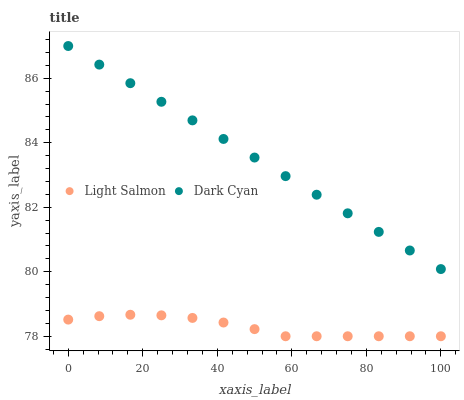Does Light Salmon have the minimum area under the curve?
Answer yes or no. Yes. Does Dark Cyan have the maximum area under the curve?
Answer yes or no. Yes. Does Light Salmon have the maximum area under the curve?
Answer yes or no. No. Is Dark Cyan the smoothest?
Answer yes or no. Yes. Is Light Salmon the roughest?
Answer yes or no. Yes. Is Light Salmon the smoothest?
Answer yes or no. No. Does Light Salmon have the lowest value?
Answer yes or no. Yes. Does Dark Cyan have the highest value?
Answer yes or no. Yes. Does Light Salmon have the highest value?
Answer yes or no. No. Is Light Salmon less than Dark Cyan?
Answer yes or no. Yes. Is Dark Cyan greater than Light Salmon?
Answer yes or no. Yes. Does Light Salmon intersect Dark Cyan?
Answer yes or no. No. 